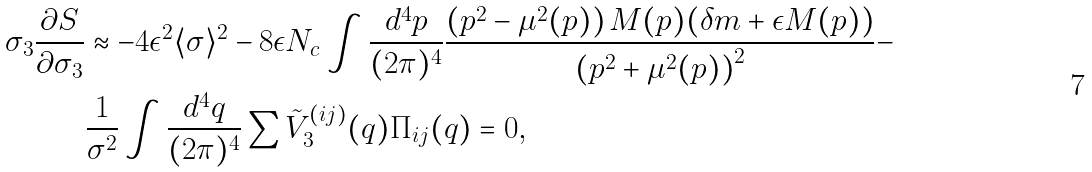Convert formula to latex. <formula><loc_0><loc_0><loc_500><loc_500>\sigma _ { 3 } \frac { \partial S } { \partial \sigma _ { 3 } } & \approx - 4 \epsilon ^ { 2 } \langle \sigma \rangle ^ { 2 } - 8 \epsilon N _ { c } \int \frac { d ^ { 4 } p } { ( 2 \pi ) ^ { 4 } } \frac { \left ( p ^ { 2 } - \mu ^ { 2 } ( p ) \right ) M ( p ) ( \delta m + \epsilon M ( p ) ) } { \left ( p ^ { 2 } + \mu ^ { 2 } ( p ) \right ) ^ { 2 } } - \\ & \frac { 1 } { \sigma ^ { 2 } } \int \frac { d ^ { 4 } q } { ( 2 \pi ) ^ { 4 } } \sum \tilde { V } _ { 3 } ^ { ( i j ) } ( q ) \Pi _ { i j } ( q ) = 0 ,</formula> 